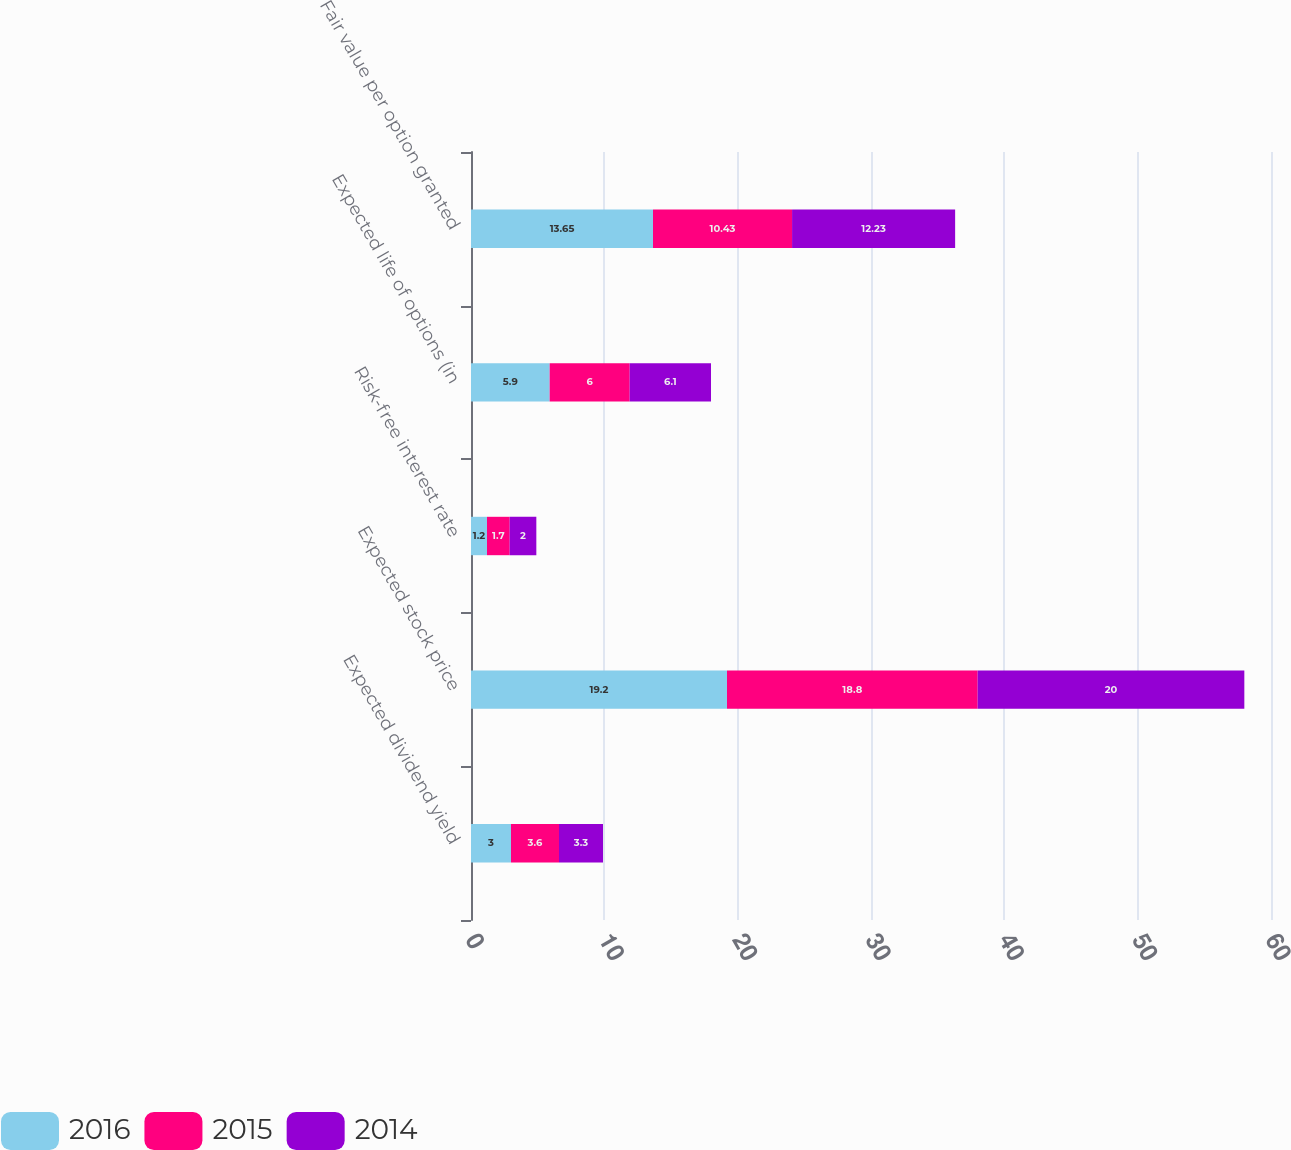Convert chart to OTSL. <chart><loc_0><loc_0><loc_500><loc_500><stacked_bar_chart><ecel><fcel>Expected dividend yield<fcel>Expected stock price<fcel>Risk-free interest rate<fcel>Expected life of options (in<fcel>Fair value per option granted<nl><fcel>2016<fcel>3<fcel>19.2<fcel>1.2<fcel>5.9<fcel>13.65<nl><fcel>2015<fcel>3.6<fcel>18.8<fcel>1.7<fcel>6<fcel>10.43<nl><fcel>2014<fcel>3.3<fcel>20<fcel>2<fcel>6.1<fcel>12.23<nl></chart> 